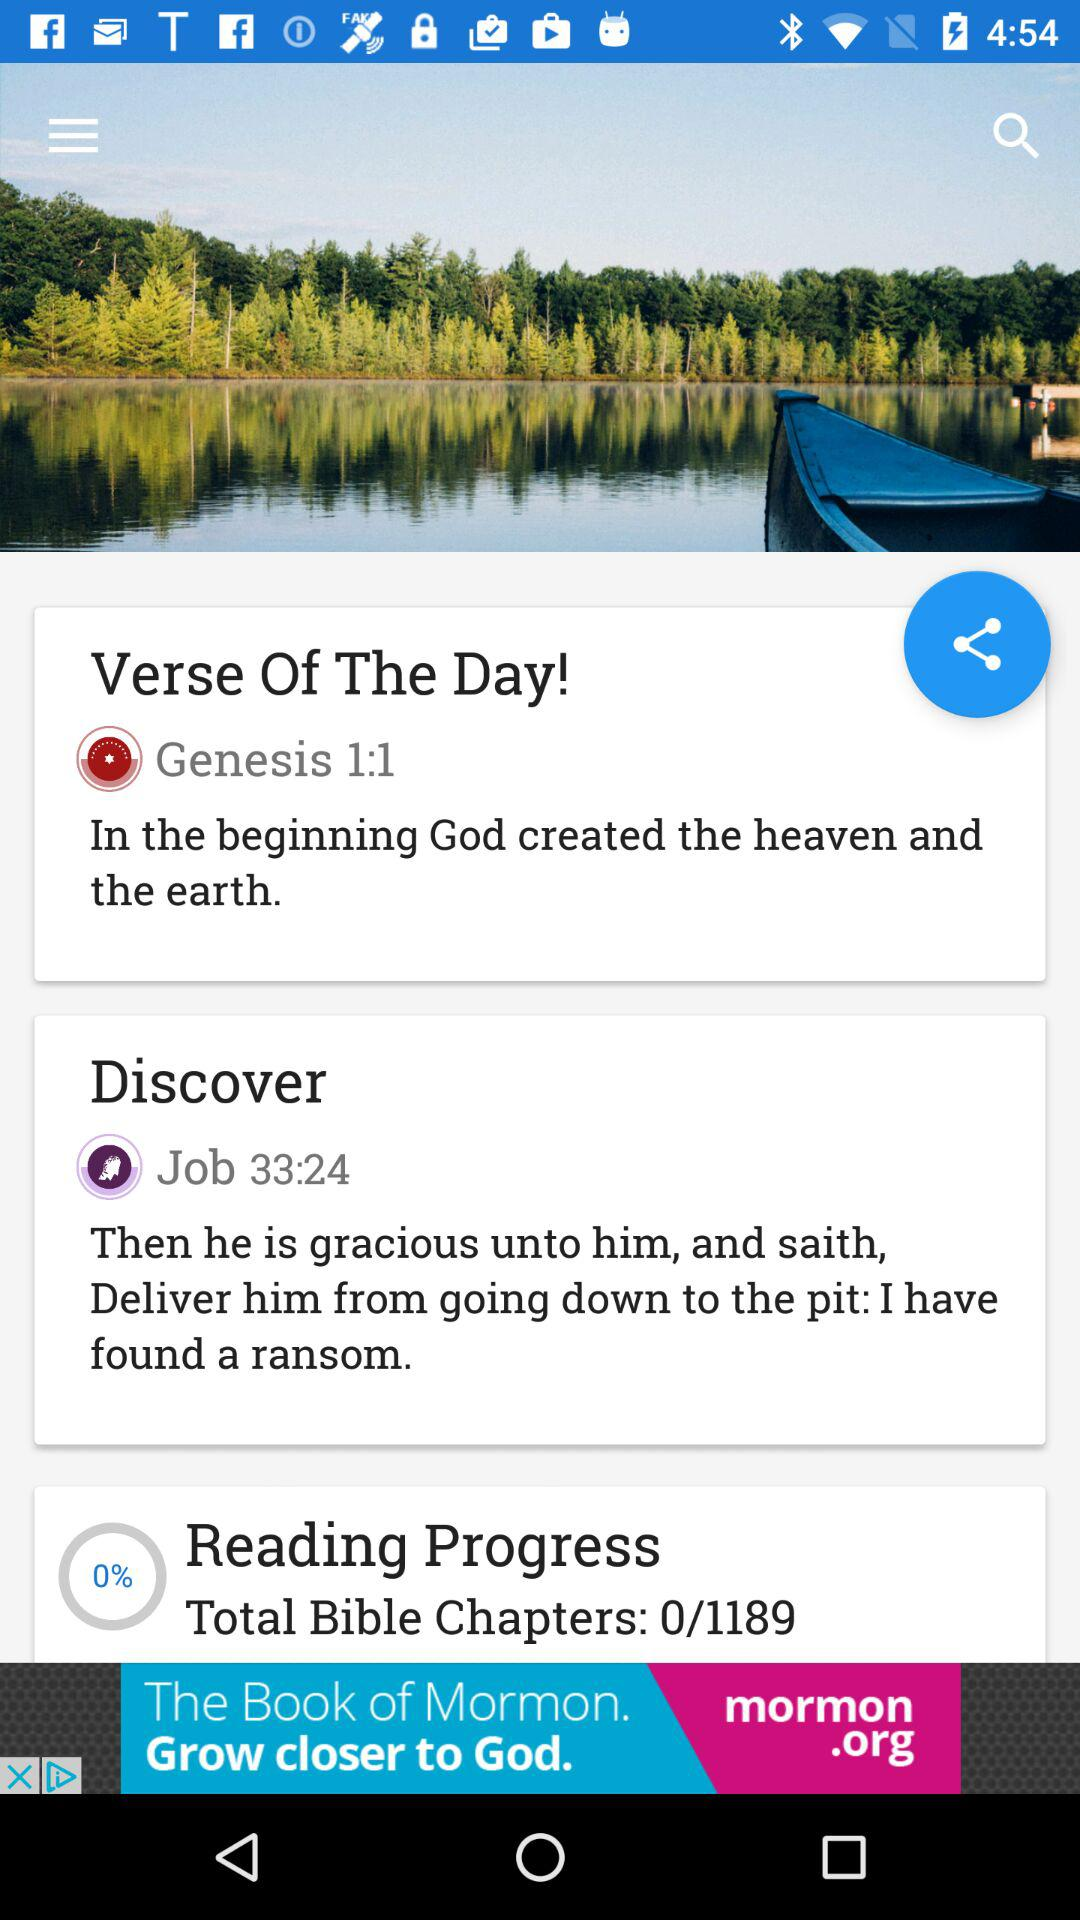What is the percentage of the reading progress? The percentage of the reading progress is 0. 